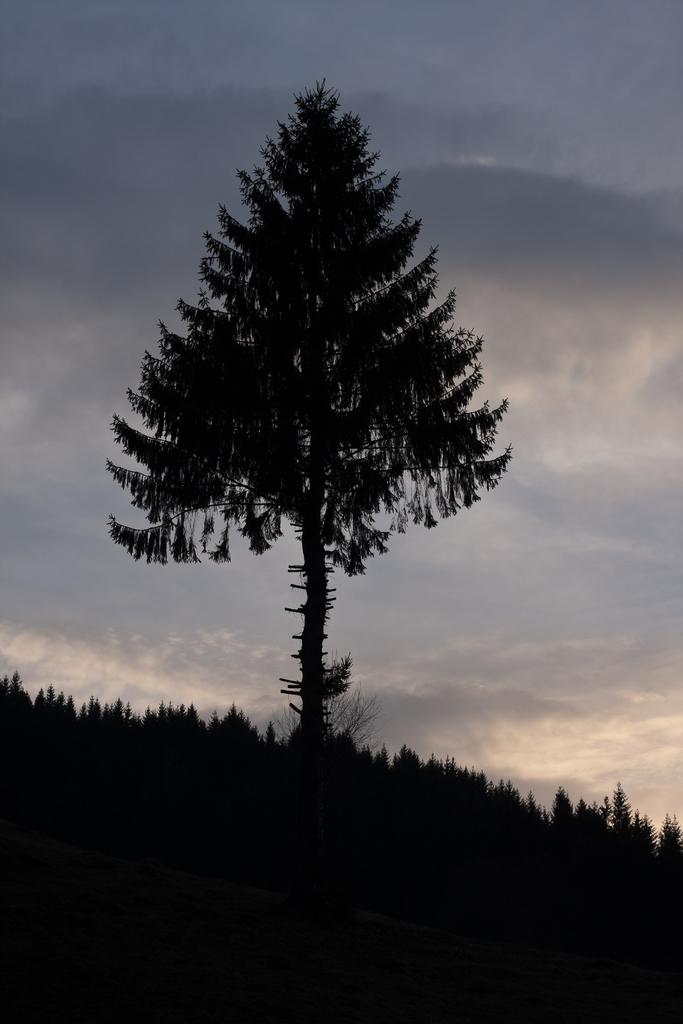What time of day does the image seem to depict? The image appears to depict an evening scene. What can be seen in the middle of the image? There is a tree in the middle of the image. How would you describe the sky in the image? The sky is cloudy in the image. How many tramps are visible in the image? There are no tramps present in the image. Can you tell me the price of the ticket in the image? There is no ticket present in the image. 